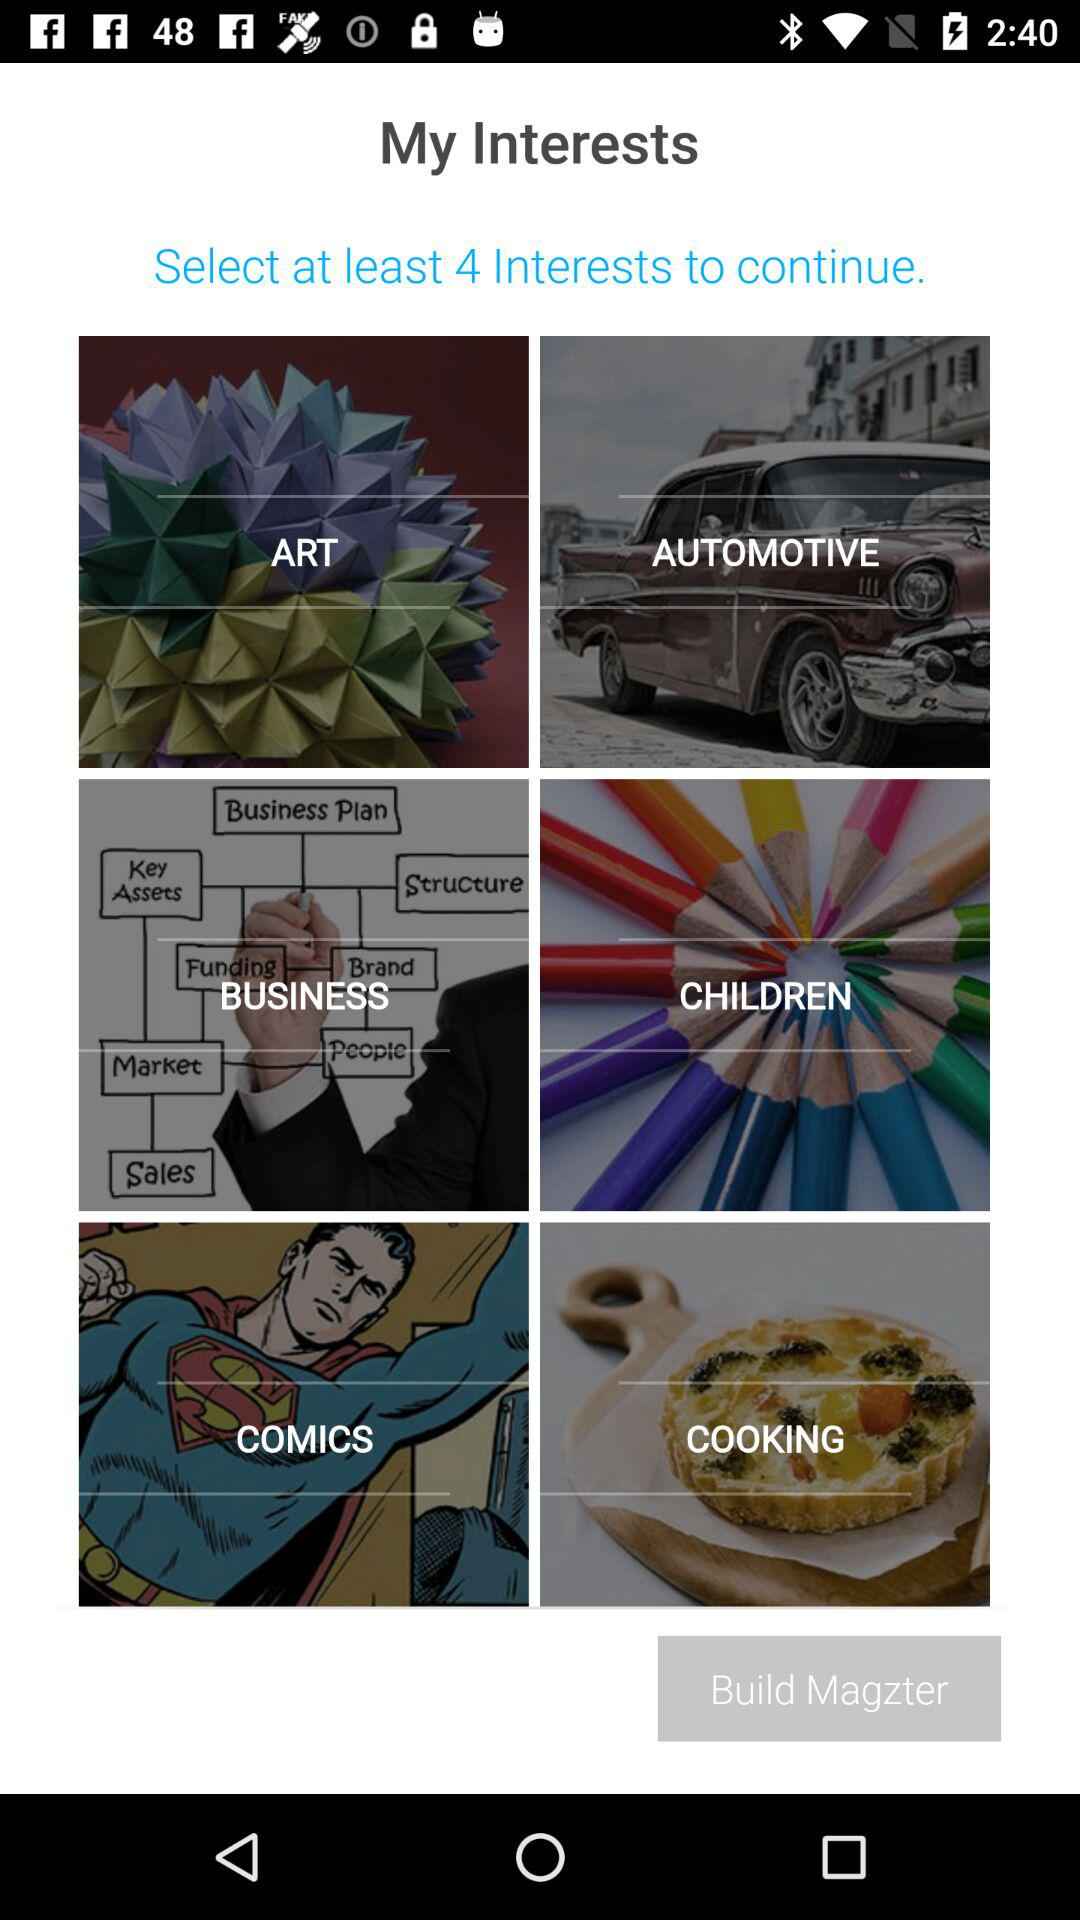How many interests are in the first two rows?
Answer the question using a single word or phrase. 4 